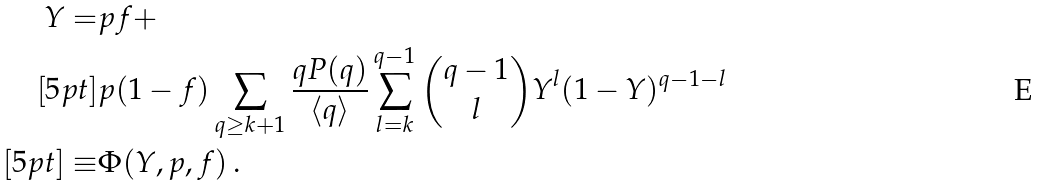<formula> <loc_0><loc_0><loc_500><loc_500>Y = & p f + \\ [ 5 p t ] & p ( 1 - f ) \sum _ { q \geq k + 1 } \frac { q P ( q ) } { \langle q \rangle } \sum _ { l = k } ^ { q - 1 } \binom { q - 1 } { l } Y ^ { l } ( 1 - Y ) ^ { q - 1 - l } \\ [ 5 p t ] \equiv & \Phi ( Y , p , f ) \, .</formula> 